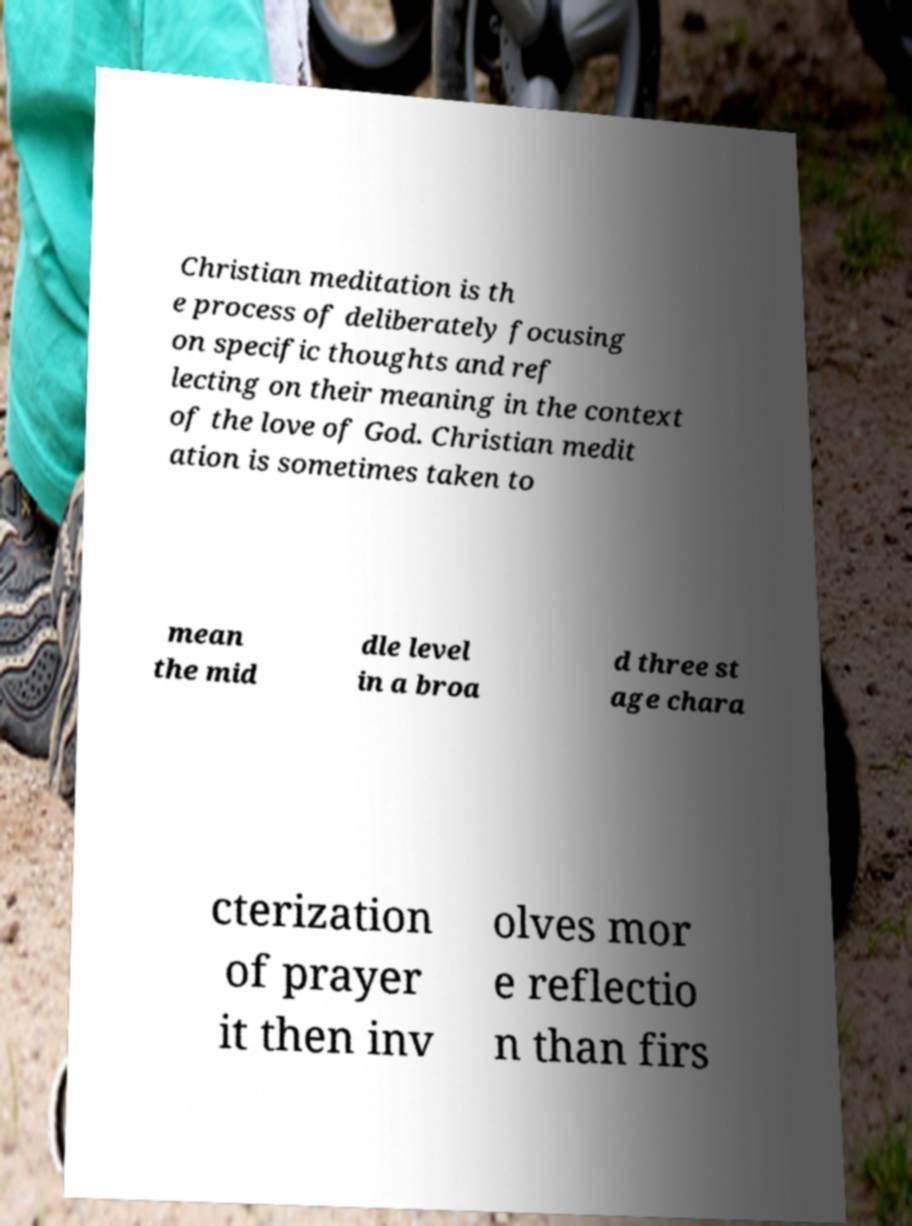Could you extract and type out the text from this image? Christian meditation is th e process of deliberately focusing on specific thoughts and ref lecting on their meaning in the context of the love of God. Christian medit ation is sometimes taken to mean the mid dle level in a broa d three st age chara cterization of prayer it then inv olves mor e reflectio n than firs 